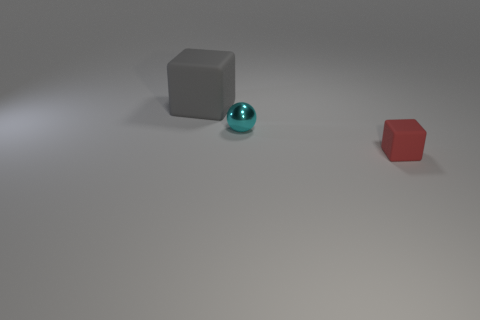Is there anything else that is the same size as the gray matte object?
Provide a succinct answer. No. Are there any other things that have the same material as the cyan ball?
Your answer should be very brief. No. There is a matte thing on the left side of the tiny red block; what is its size?
Ensure brevity in your answer.  Large. There is a thing that is behind the cyan object; is there a big gray cube that is on the right side of it?
Offer a terse response. No. How many other things are the same shape as the cyan object?
Give a very brief answer. 0. Is the shape of the large rubber object the same as the small matte thing?
Keep it short and to the point. Yes. There is a thing that is both on the right side of the big matte thing and behind the small rubber object; what color is it?
Offer a very short reply. Cyan. How many large objects are purple matte things or cyan metal spheres?
Offer a very short reply. 0. Are there any other things that are the same color as the large object?
Give a very brief answer. No. The cube on the left side of the rubber block that is on the right side of the shiny object that is right of the large matte object is made of what material?
Keep it short and to the point. Rubber. 